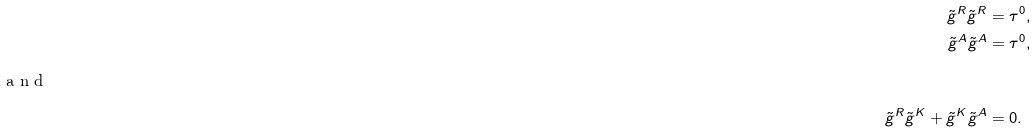Convert formula to latex. <formula><loc_0><loc_0><loc_500><loc_500>\tilde { g } ^ { R } \tilde { g } ^ { R } & = \tau ^ { 0 } , \\ \tilde { g } ^ { A } \tilde { g } ^ { A } & = \tau ^ { 0 } , \\ \intertext { a n d } \tilde { g } ^ { R } \tilde { g } ^ { K } + \tilde { g } ^ { K } \tilde { g } ^ { A } & = 0 .</formula> 